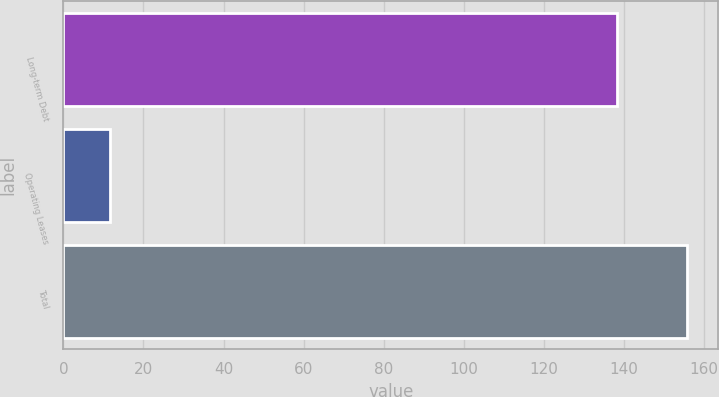<chart> <loc_0><loc_0><loc_500><loc_500><bar_chart><fcel>Long-term Debt<fcel>Operating Leases<fcel>Total<nl><fcel>138.2<fcel>11.6<fcel>155.8<nl></chart> 